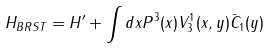<formula> <loc_0><loc_0><loc_500><loc_500>H _ { B R S T } = H ^ { \prime } + \int d x P ^ { 3 } ( x ) V ^ { 1 } _ { 3 } ( x , y ) \bar { C } _ { 1 } ( y )</formula> 